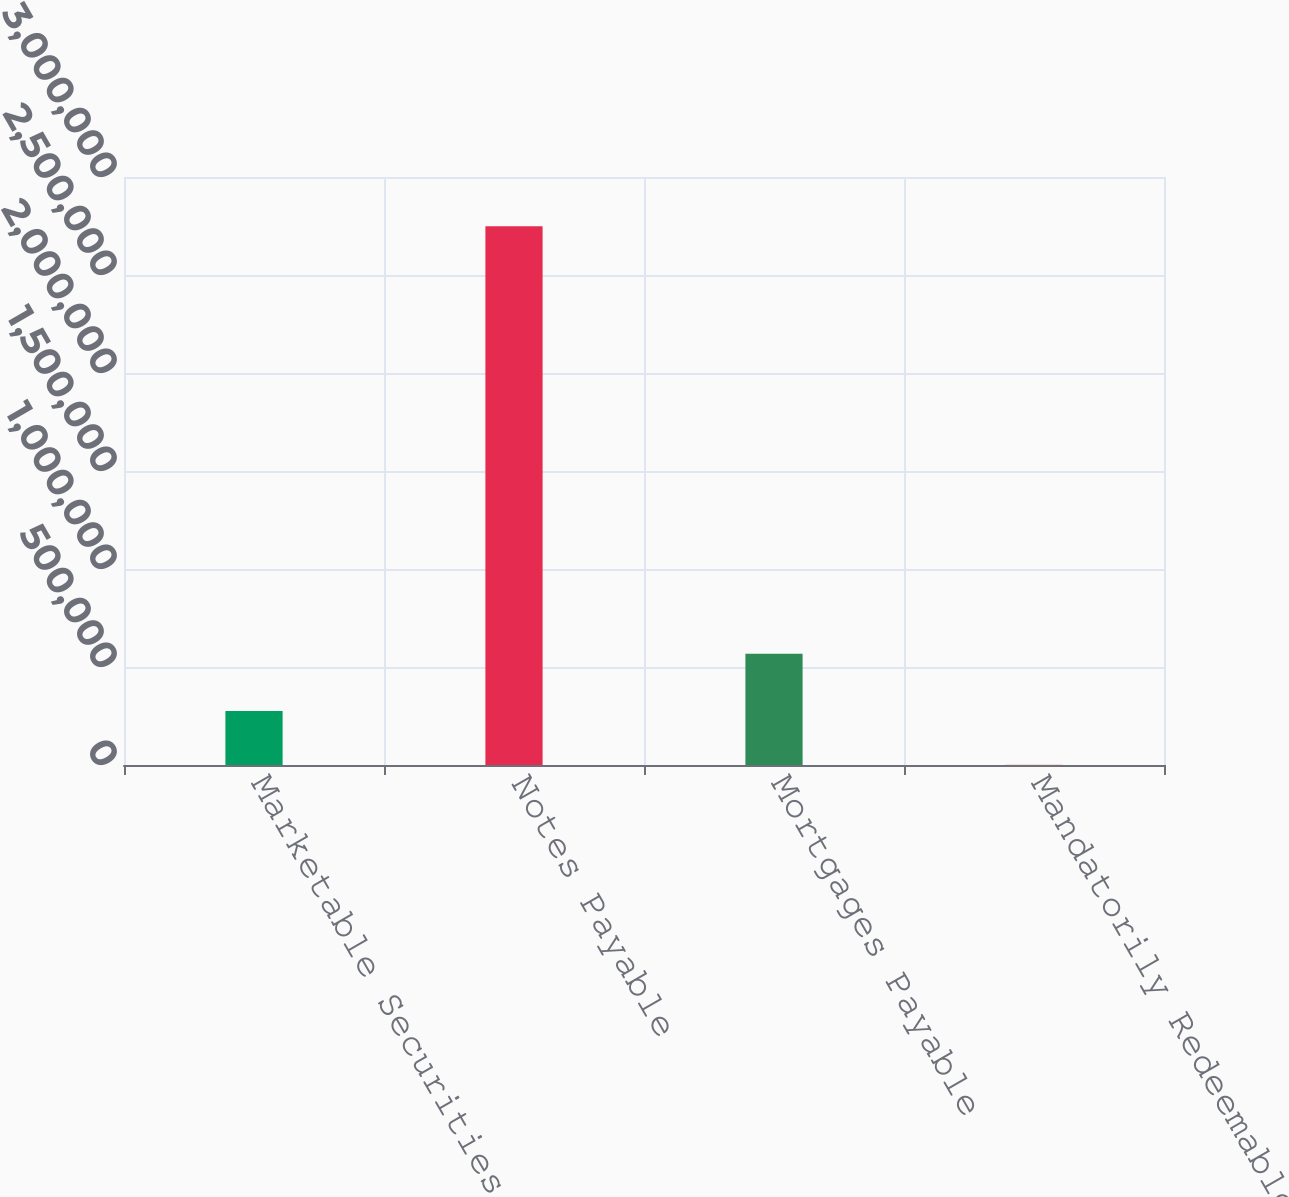<chart> <loc_0><loc_0><loc_500><loc_500><bar_chart><fcel>Marketable Securities<fcel>Notes Payable<fcel>Mortgages Payable<fcel>Mandatorily Redeemable<nl><fcel>275971<fcel>2.74834e+06<fcel>567917<fcel>1263<nl></chart> 